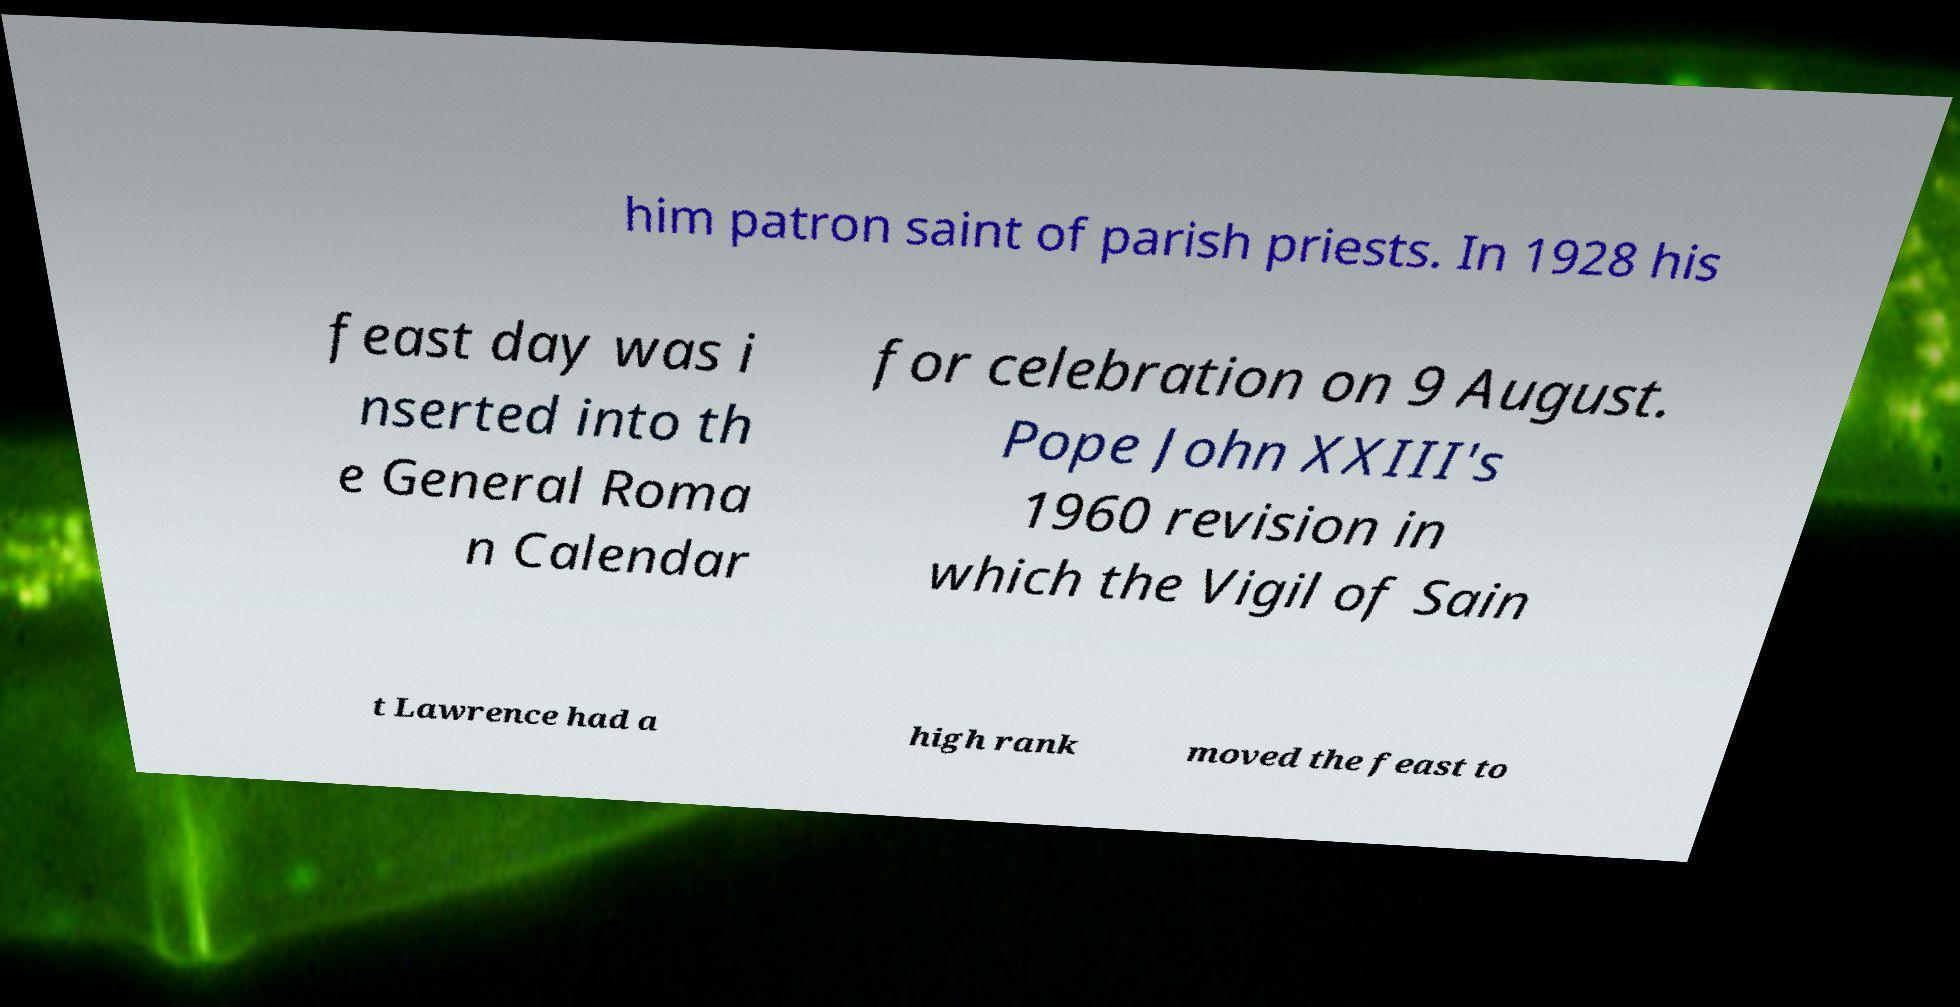Can you read and provide the text displayed in the image?This photo seems to have some interesting text. Can you extract and type it out for me? him patron saint of parish priests. In 1928 his feast day was i nserted into th e General Roma n Calendar for celebration on 9 August. Pope John XXIII's 1960 revision in which the Vigil of Sain t Lawrence had a high rank moved the feast to 